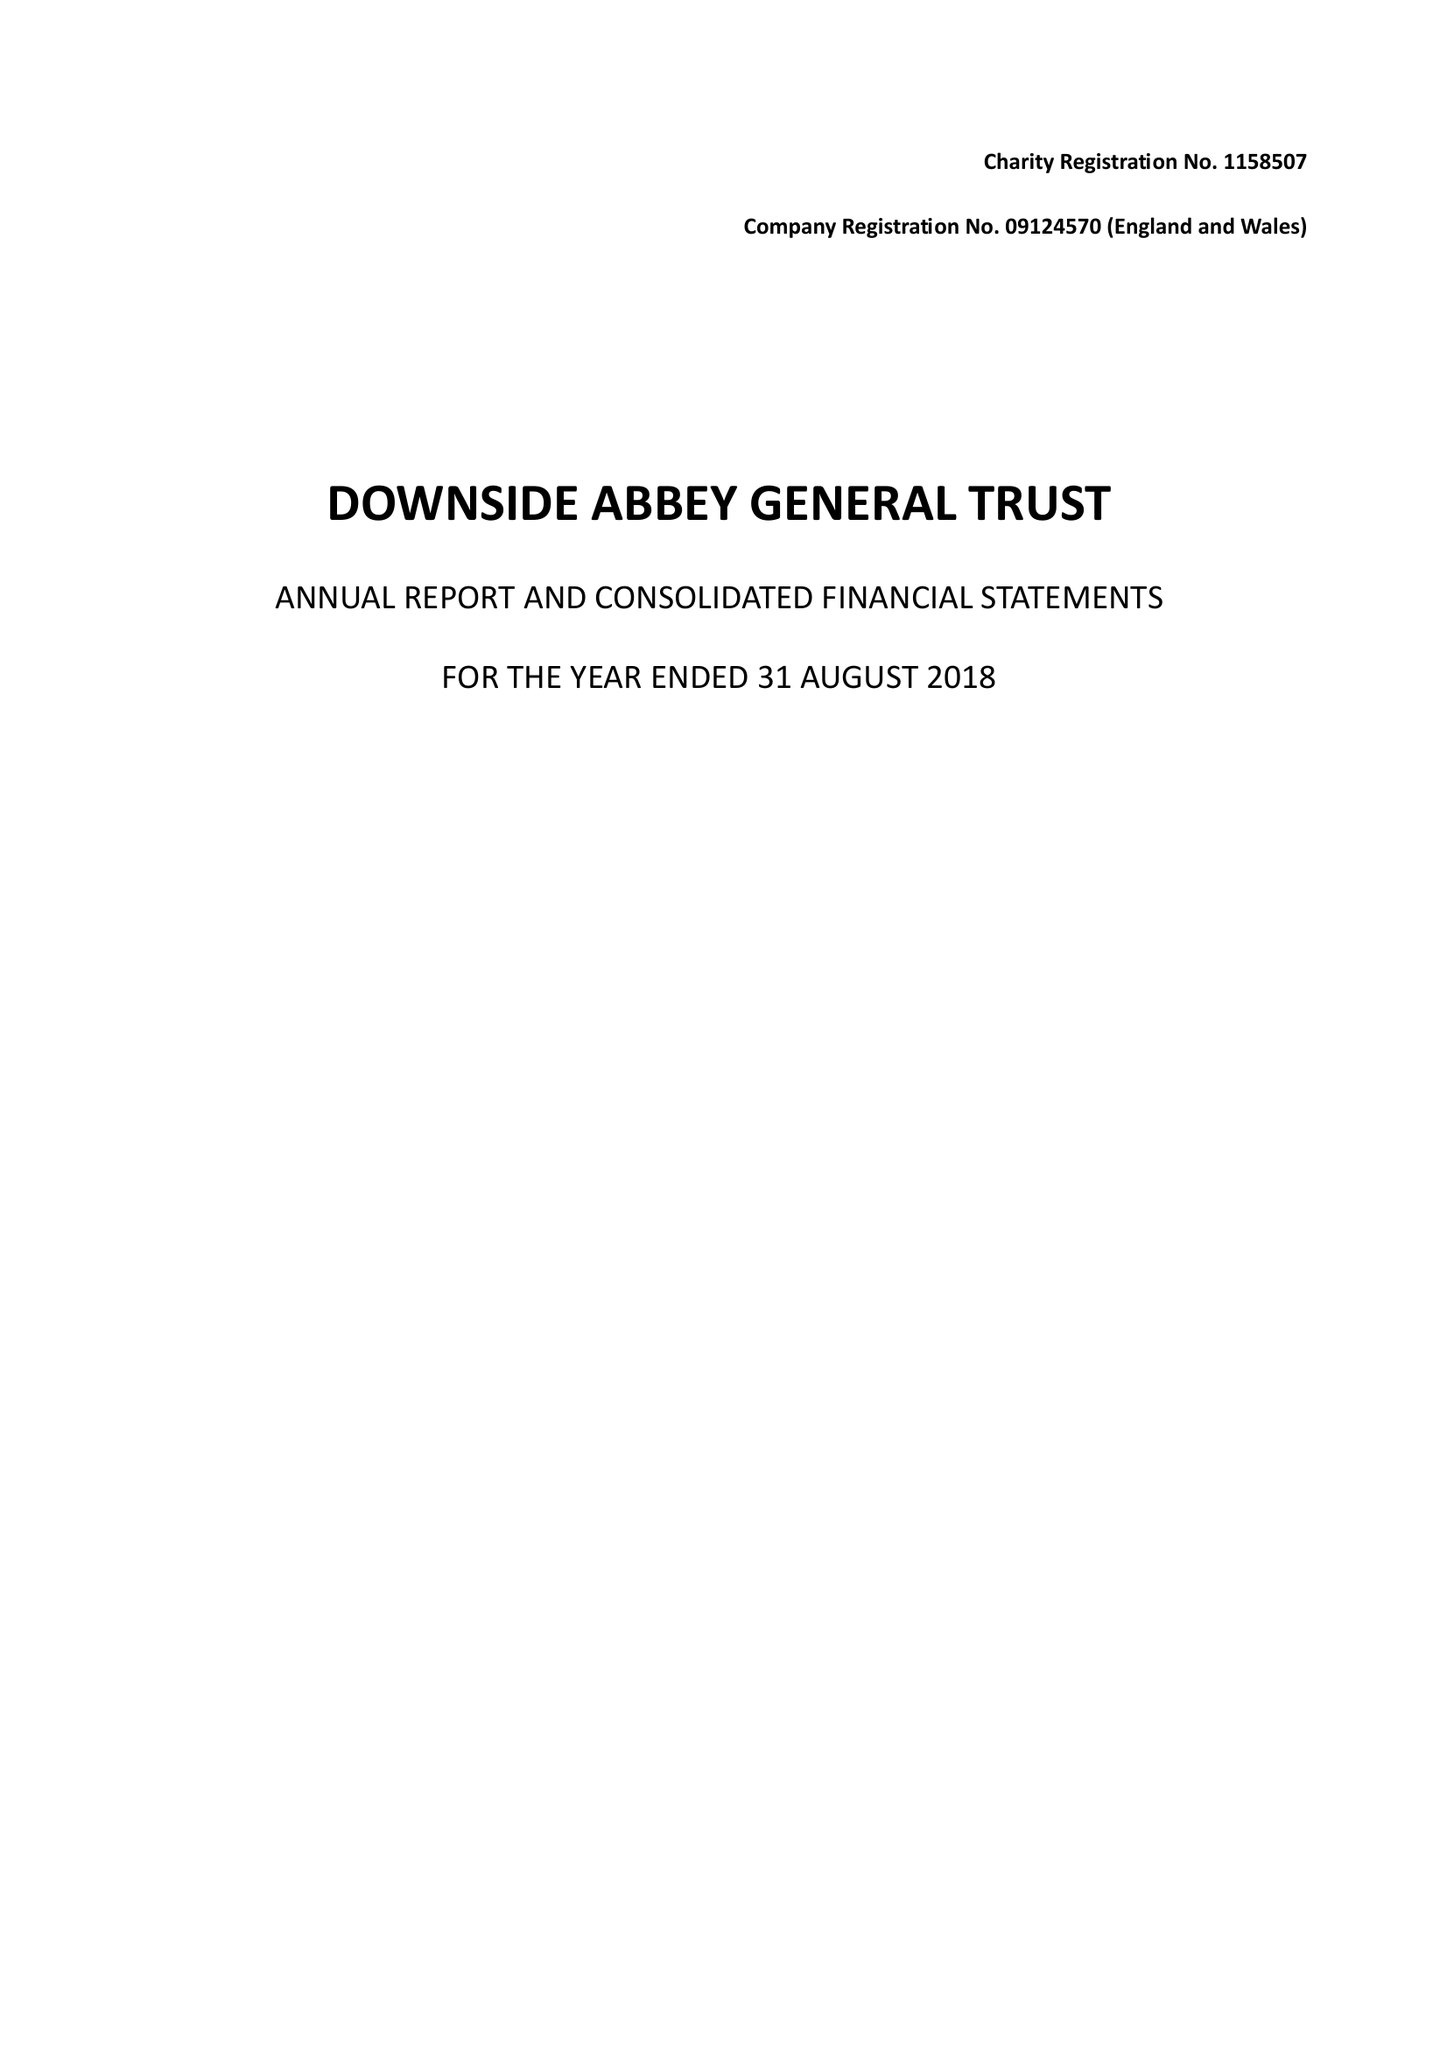What is the value for the charity_number?
Answer the question using a single word or phrase. 1158507 